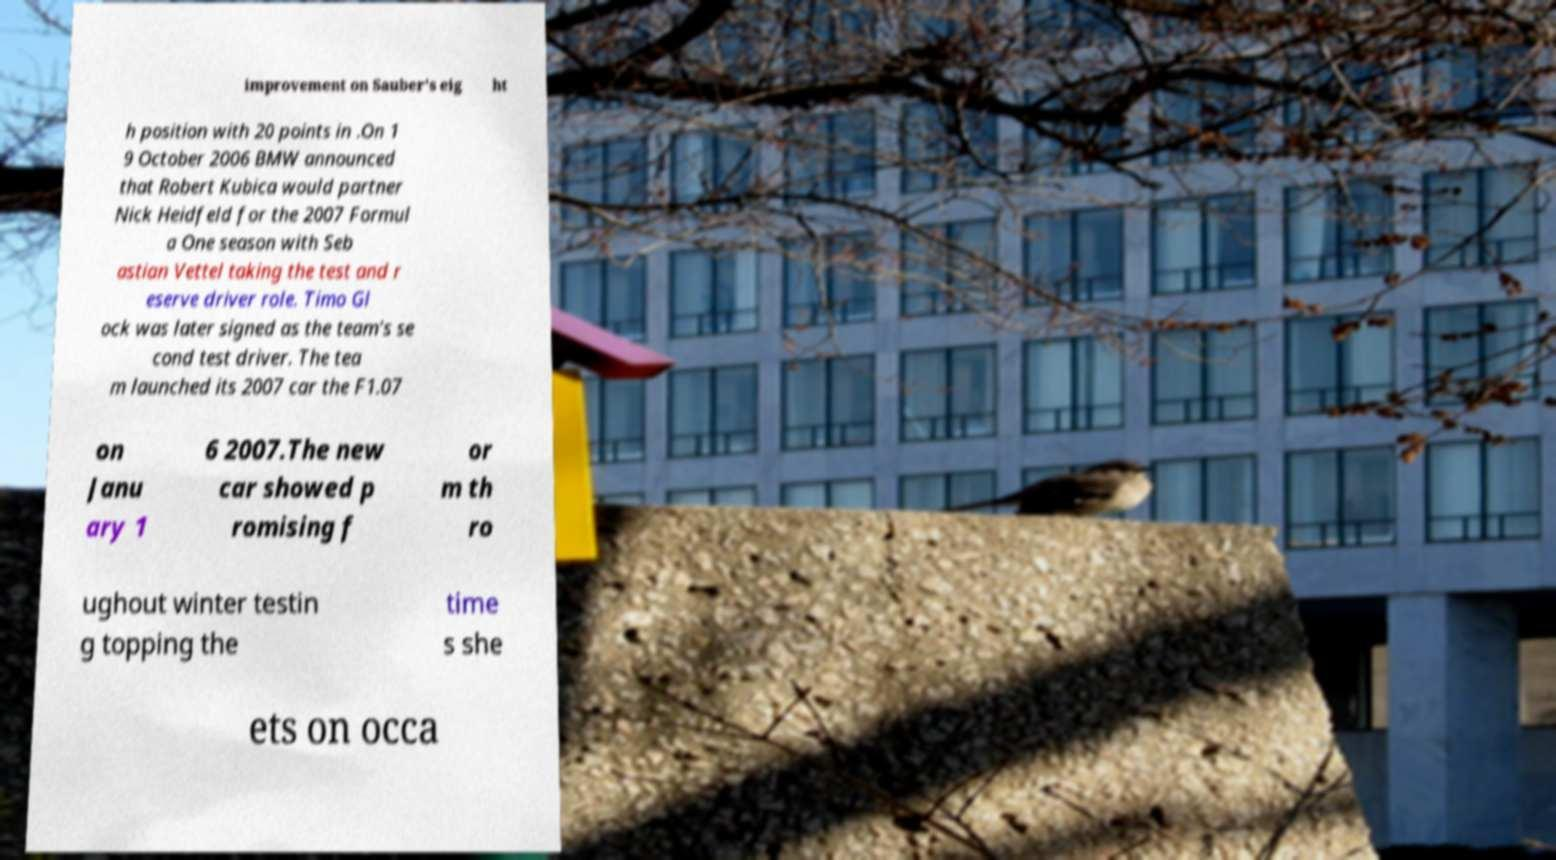What messages or text are displayed in this image? I need them in a readable, typed format. improvement on Sauber's eig ht h position with 20 points in .On 1 9 October 2006 BMW announced that Robert Kubica would partner Nick Heidfeld for the 2007 Formul a One season with Seb astian Vettel taking the test and r eserve driver role. Timo Gl ock was later signed as the team's se cond test driver. The tea m launched its 2007 car the F1.07 on Janu ary 1 6 2007.The new car showed p romising f or m th ro ughout winter testin g topping the time s she ets on occa 